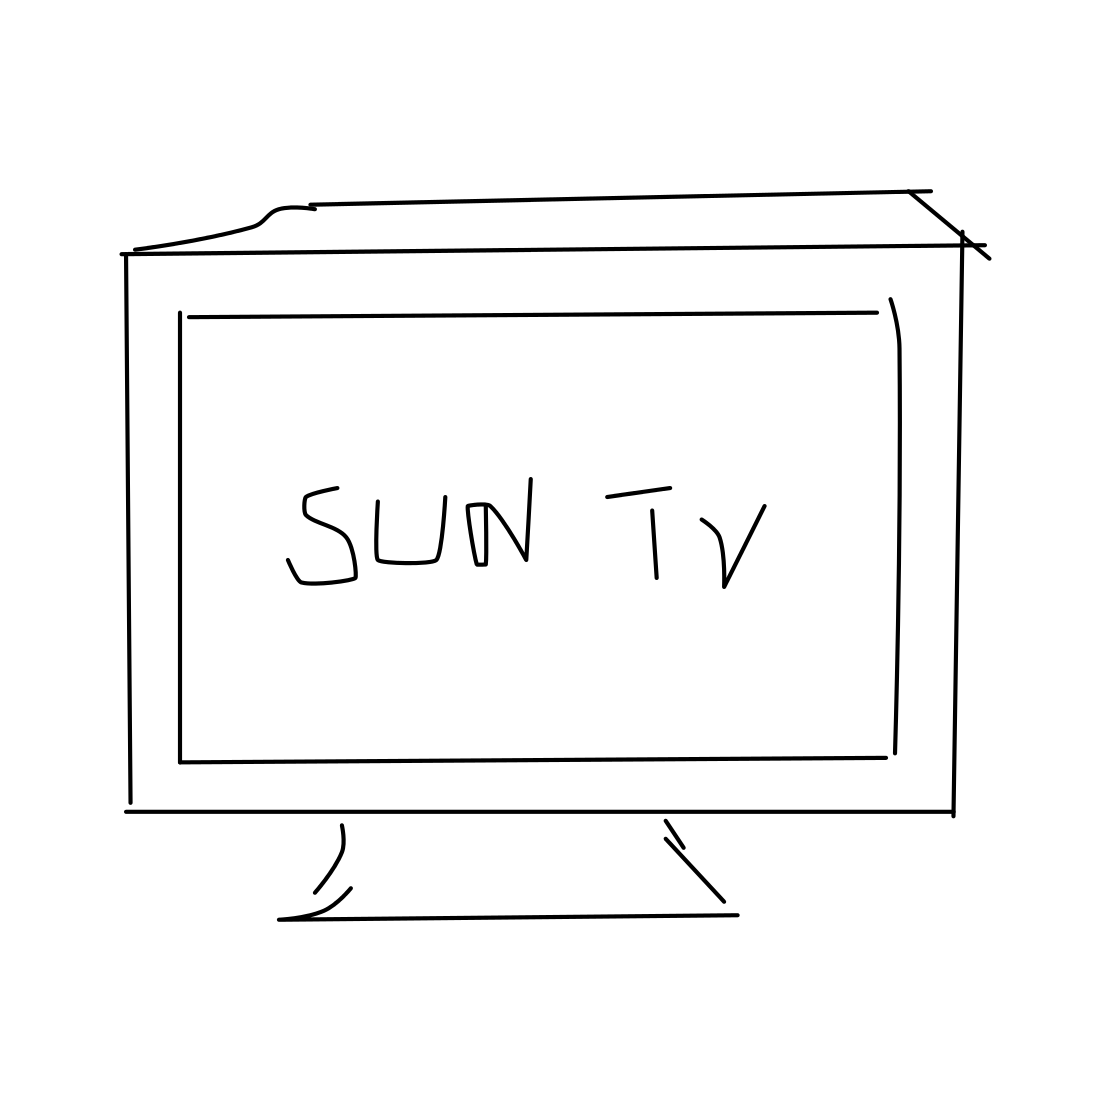What type of device is shown in the picture? The picture shows a stylized representation of a television, characterized by its screen and stand. What does the text 'SUN TV' on the screen suggest? The text 'SUN TV' appears to be a placeholder or a fictitious channel name, typically this could indicate a brand or a specific television channel in a real-life context. 